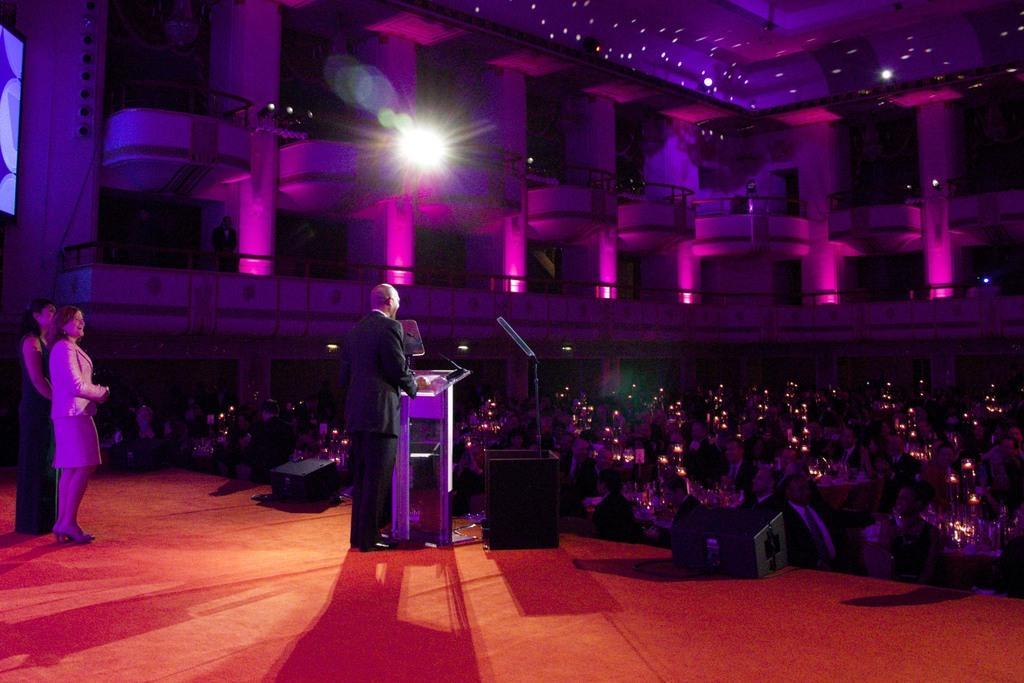In one or two sentences, can you explain what this image depicts? In this picture there are two ladies on the left side of the image and there is a man on the left side of the image, there is a mic and a desk in front of him and there are people those who are sitting around the tables, on the right side of the image, there are two storeys at the top side of the image. 